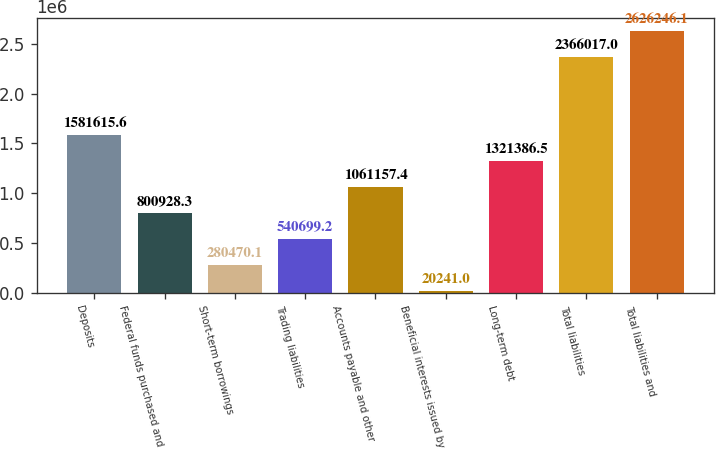Convert chart to OTSL. <chart><loc_0><loc_0><loc_500><loc_500><bar_chart><fcel>Deposits<fcel>Federal funds purchased and<fcel>Short-term borrowings<fcel>Trading liabilities<fcel>Accounts payable and other<fcel>Beneficial interests issued by<fcel>Long-term debt<fcel>Total liabilities<fcel>Total liabilities and<nl><fcel>1.58162e+06<fcel>800928<fcel>280470<fcel>540699<fcel>1.06116e+06<fcel>20241<fcel>1.32139e+06<fcel>2.36602e+06<fcel>2.62625e+06<nl></chart> 